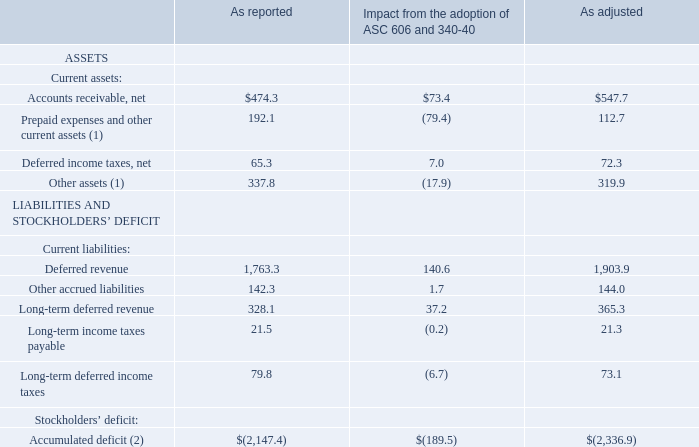The following table shows select line items that were materially impacted by the adoption of ASC Topics 606 and 340-40 on Autodesk’s Consolidated Balance Sheet as of January 31, 2019:
(1) Short term and long term "contract assets" under ASC Topic 606 are included within "Prepaid expenses and other current assets" and "Other assets", respectively, on the Consolidated Balance Sheet
(2) Included in the "Accumulated deficit" adjustment is $179.4 million for the cumulative effect adjustment of adopting ASC Topic 606 and 340-40 on the opening balance as of February 1, 2018.
Adoption of the standard had no impact to net cash provided by or (used in) operating, financing, or investing activities on the Company’s Consolidated Statements of Cash Flows
Where are the short term and long term "contract assets" under ASC Topic 606? Within "prepaid expenses and other current assets" and "other assets", respectively,. What is the impact the standard on net cash provided in financing? No impact. What is the net adjusted accounts receivable?
Answer scale should be: million. $547.7. What would be the accumulated deficit adjustment without the  $179.4 million adjustment for adopting ASC Topic 606 and 340-40 on the opening balance as of February 1, 2018?
Answer scale should be: million. 189.5-179.4
Answer: 10.1. What is the reported current ratio?  (474.3+192.1+65.3+337.8)/(1,763.3+142.3+328.1+21.5+79.8)
Answer: 0.46. How much did the deferred revenue change due to the adoption of ASC 606 and 340-40?
Answer scale should be: percent. 140.6/1,763.3 
Answer: 7.97. 